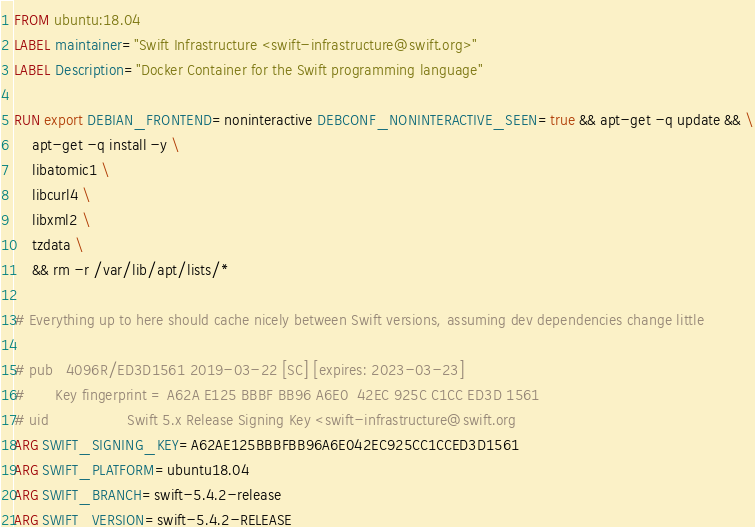Convert code to text. <code><loc_0><loc_0><loc_500><loc_500><_Dockerfile_>FROM ubuntu:18.04
LABEL maintainer="Swift Infrastructure <swift-infrastructure@swift.org>"
LABEL Description="Docker Container for the Swift programming language"

RUN export DEBIAN_FRONTEND=noninteractive DEBCONF_NONINTERACTIVE_SEEN=true && apt-get -q update && \
    apt-get -q install -y \
    libatomic1 \
    libcurl4 \
    libxml2 \
    tzdata \
    && rm -r /var/lib/apt/lists/*

# Everything up to here should cache nicely between Swift versions, assuming dev dependencies change little

# pub   4096R/ED3D1561 2019-03-22 [SC] [expires: 2023-03-23]
#       Key fingerprint = A62A E125 BBBF BB96 A6E0  42EC 925C C1CC ED3D 1561
# uid                  Swift 5.x Release Signing Key <swift-infrastructure@swift.org
ARG SWIFT_SIGNING_KEY=A62AE125BBBFBB96A6E042EC925CC1CCED3D1561
ARG SWIFT_PLATFORM=ubuntu18.04
ARG SWIFT_BRANCH=swift-5.4.2-release
ARG SWIFT_VERSION=swift-5.4.2-RELEASE</code> 